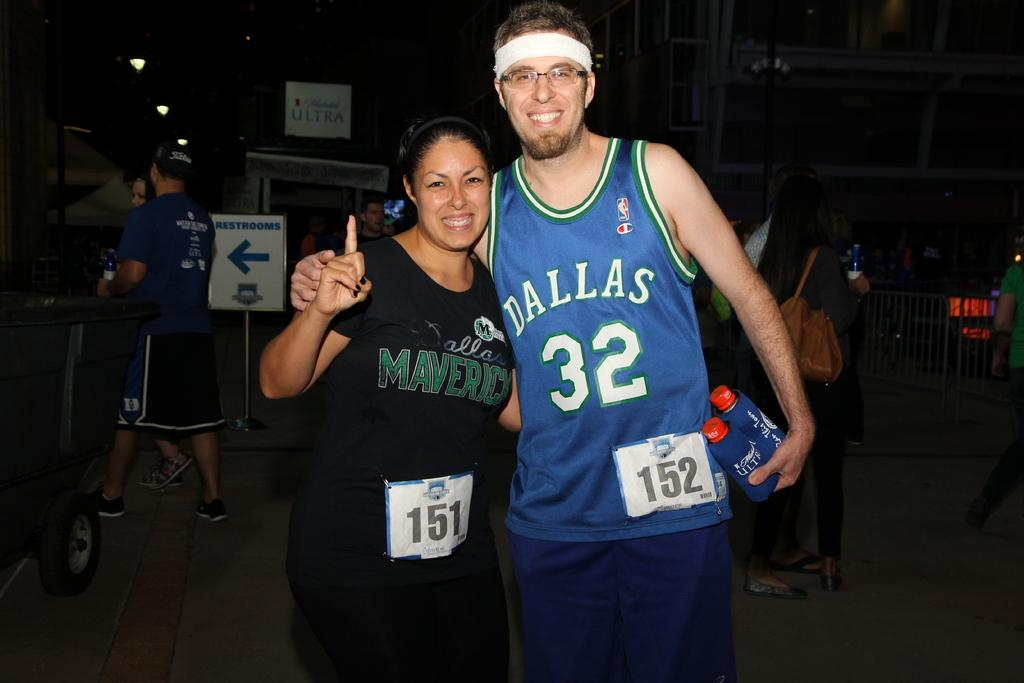<image>
Present a compact description of the photo's key features. A woman in a black Mavericks shirt standing next to a member of the team. 